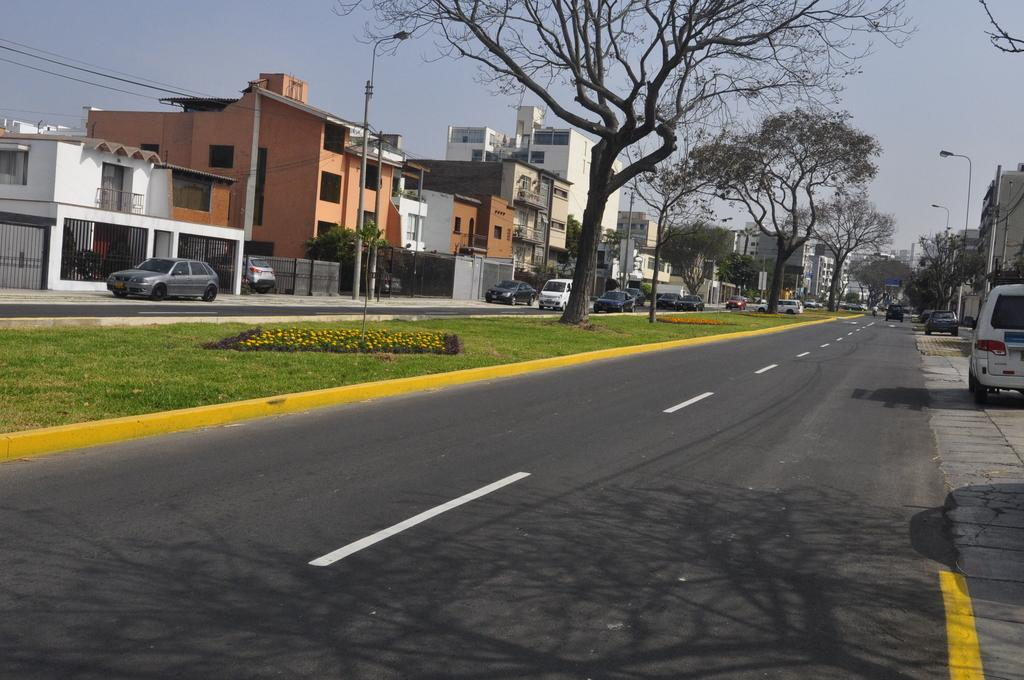What can be seen on the road in the image? There are vehicles on the road in the image. What objects are present in the image that might be used for supporting or guiding? There are poles in the image. What can be seen illuminating the scene in the image? There are lights in the image. What type of vegetation is present in the image? There are flowers and grass in the image. What type of structures are visible in the image? There are buildings in the image. What type of natural features are present in the image? There are trees in the image. What part of the natural environment is visible in the background of the image? The sky is visible in the background of the image. What type of bells can be heard ringing in the image? There are no bells present in the image, and therefore no sound can be heard. How does the control panel in the image operate? There is no control panel present in the image. 